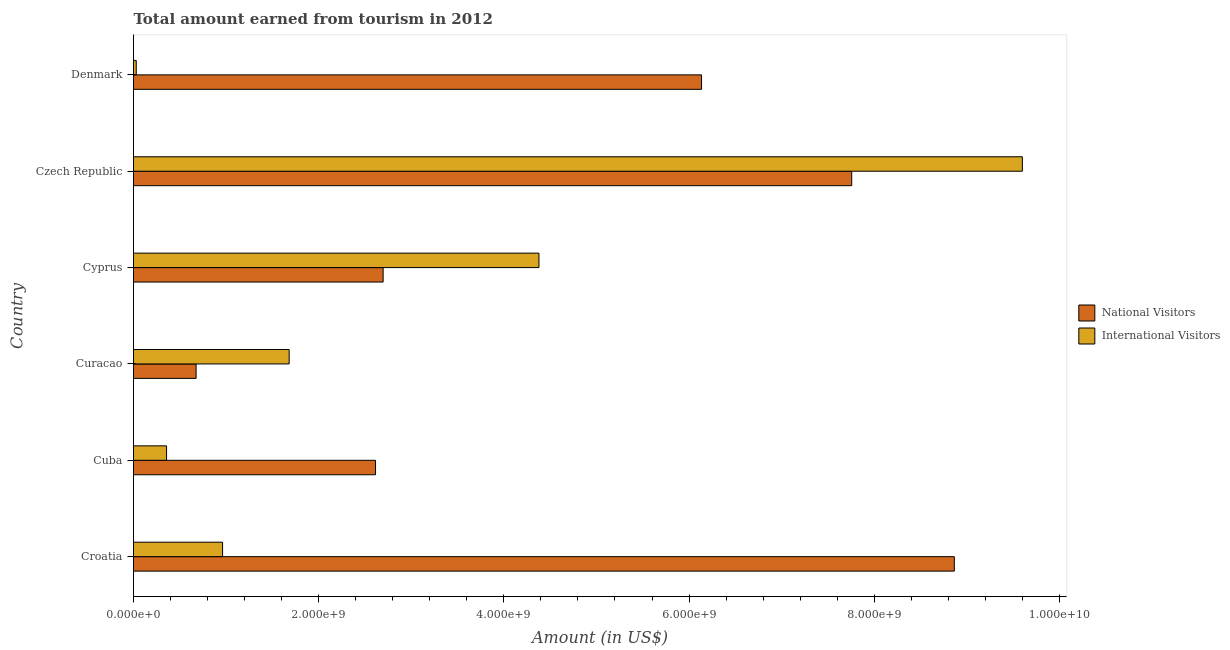Are the number of bars on each tick of the Y-axis equal?
Provide a succinct answer. Yes. How many bars are there on the 6th tick from the bottom?
Provide a short and direct response. 2. What is the label of the 3rd group of bars from the top?
Your response must be concise. Cyprus. In how many cases, is the number of bars for a given country not equal to the number of legend labels?
Offer a terse response. 0. What is the amount earned from national visitors in Cyprus?
Make the answer very short. 2.70e+09. Across all countries, what is the maximum amount earned from international visitors?
Offer a very short reply. 9.60e+09. Across all countries, what is the minimum amount earned from national visitors?
Offer a very short reply. 6.76e+08. In which country was the amount earned from international visitors maximum?
Your answer should be compact. Czech Republic. What is the total amount earned from international visitors in the graph?
Give a very brief answer. 1.70e+1. What is the difference between the amount earned from international visitors in Curacao and that in Czech Republic?
Your answer should be compact. -7.92e+09. What is the difference between the amount earned from international visitors in Curacao and the amount earned from national visitors in Denmark?
Make the answer very short. -4.45e+09. What is the average amount earned from national visitors per country?
Keep it short and to the point. 4.79e+09. What is the difference between the amount earned from national visitors and amount earned from international visitors in Denmark?
Your answer should be compact. 6.11e+09. In how many countries, is the amount earned from national visitors greater than 2800000000 US$?
Keep it short and to the point. 3. What is the ratio of the amount earned from international visitors in Cuba to that in Cyprus?
Offer a very short reply. 0.08. Is the difference between the amount earned from national visitors in Curacao and Czech Republic greater than the difference between the amount earned from international visitors in Curacao and Czech Republic?
Your answer should be compact. Yes. What is the difference between the highest and the second highest amount earned from national visitors?
Make the answer very short. 1.11e+09. What is the difference between the highest and the lowest amount earned from international visitors?
Keep it short and to the point. 9.57e+09. In how many countries, is the amount earned from international visitors greater than the average amount earned from international visitors taken over all countries?
Your response must be concise. 2. Is the sum of the amount earned from national visitors in Curacao and Czech Republic greater than the maximum amount earned from international visitors across all countries?
Keep it short and to the point. No. What does the 2nd bar from the top in Cuba represents?
Provide a short and direct response. National Visitors. What does the 2nd bar from the bottom in Curacao represents?
Offer a terse response. International Visitors. How many bars are there?
Provide a short and direct response. 12. What is the difference between two consecutive major ticks on the X-axis?
Your answer should be very brief. 2.00e+09. Are the values on the major ticks of X-axis written in scientific E-notation?
Your response must be concise. Yes. Does the graph contain any zero values?
Provide a short and direct response. No. Where does the legend appear in the graph?
Provide a succinct answer. Center right. What is the title of the graph?
Make the answer very short. Total amount earned from tourism in 2012. Does "National Tourists" appear as one of the legend labels in the graph?
Give a very brief answer. No. What is the Amount (in US$) of National Visitors in Croatia?
Offer a very short reply. 8.86e+09. What is the Amount (in US$) in International Visitors in Croatia?
Your answer should be compact. 9.62e+08. What is the Amount (in US$) of National Visitors in Cuba?
Your response must be concise. 2.61e+09. What is the Amount (in US$) in International Visitors in Cuba?
Offer a very short reply. 3.57e+08. What is the Amount (in US$) of National Visitors in Curacao?
Your answer should be compact. 6.76e+08. What is the Amount (in US$) of International Visitors in Curacao?
Ensure brevity in your answer.  1.68e+09. What is the Amount (in US$) of National Visitors in Cyprus?
Offer a terse response. 2.70e+09. What is the Amount (in US$) in International Visitors in Cyprus?
Provide a short and direct response. 4.38e+09. What is the Amount (in US$) in National Visitors in Czech Republic?
Your answer should be very brief. 7.76e+09. What is the Amount (in US$) in International Visitors in Czech Republic?
Your response must be concise. 9.60e+09. What is the Amount (in US$) in National Visitors in Denmark?
Give a very brief answer. 6.14e+09. What is the Amount (in US$) in International Visitors in Denmark?
Offer a terse response. 2.96e+07. Across all countries, what is the maximum Amount (in US$) in National Visitors?
Your answer should be compact. 8.86e+09. Across all countries, what is the maximum Amount (in US$) of International Visitors?
Provide a short and direct response. 9.60e+09. Across all countries, what is the minimum Amount (in US$) in National Visitors?
Provide a succinct answer. 6.76e+08. Across all countries, what is the minimum Amount (in US$) in International Visitors?
Your response must be concise. 2.96e+07. What is the total Amount (in US$) in National Visitors in the graph?
Ensure brevity in your answer.  2.87e+1. What is the total Amount (in US$) in International Visitors in the graph?
Keep it short and to the point. 1.70e+1. What is the difference between the Amount (in US$) of National Visitors in Croatia and that in Cuba?
Your answer should be very brief. 6.25e+09. What is the difference between the Amount (in US$) in International Visitors in Croatia and that in Cuba?
Give a very brief answer. 6.05e+08. What is the difference between the Amount (in US$) in National Visitors in Croatia and that in Curacao?
Keep it short and to the point. 8.19e+09. What is the difference between the Amount (in US$) in International Visitors in Croatia and that in Curacao?
Give a very brief answer. -7.19e+08. What is the difference between the Amount (in US$) of National Visitors in Croatia and that in Cyprus?
Provide a short and direct response. 6.17e+09. What is the difference between the Amount (in US$) of International Visitors in Croatia and that in Cyprus?
Provide a short and direct response. -3.42e+09. What is the difference between the Amount (in US$) of National Visitors in Croatia and that in Czech Republic?
Your answer should be very brief. 1.11e+09. What is the difference between the Amount (in US$) in International Visitors in Croatia and that in Czech Republic?
Ensure brevity in your answer.  -8.64e+09. What is the difference between the Amount (in US$) of National Visitors in Croatia and that in Denmark?
Offer a terse response. 2.73e+09. What is the difference between the Amount (in US$) of International Visitors in Croatia and that in Denmark?
Offer a very short reply. 9.32e+08. What is the difference between the Amount (in US$) in National Visitors in Cuba and that in Curacao?
Ensure brevity in your answer.  1.94e+09. What is the difference between the Amount (in US$) of International Visitors in Cuba and that in Curacao?
Offer a terse response. -1.32e+09. What is the difference between the Amount (in US$) of National Visitors in Cuba and that in Cyprus?
Give a very brief answer. -8.20e+07. What is the difference between the Amount (in US$) of International Visitors in Cuba and that in Cyprus?
Give a very brief answer. -4.02e+09. What is the difference between the Amount (in US$) of National Visitors in Cuba and that in Czech Republic?
Make the answer very short. -5.14e+09. What is the difference between the Amount (in US$) of International Visitors in Cuba and that in Czech Republic?
Keep it short and to the point. -9.24e+09. What is the difference between the Amount (in US$) of National Visitors in Cuba and that in Denmark?
Keep it short and to the point. -3.52e+09. What is the difference between the Amount (in US$) of International Visitors in Cuba and that in Denmark?
Offer a terse response. 3.27e+08. What is the difference between the Amount (in US$) of National Visitors in Curacao and that in Cyprus?
Provide a short and direct response. -2.02e+09. What is the difference between the Amount (in US$) in International Visitors in Curacao and that in Cyprus?
Ensure brevity in your answer.  -2.70e+09. What is the difference between the Amount (in US$) in National Visitors in Curacao and that in Czech Republic?
Provide a succinct answer. -7.08e+09. What is the difference between the Amount (in US$) in International Visitors in Curacao and that in Czech Republic?
Offer a very short reply. -7.92e+09. What is the difference between the Amount (in US$) of National Visitors in Curacao and that in Denmark?
Offer a terse response. -5.46e+09. What is the difference between the Amount (in US$) of International Visitors in Curacao and that in Denmark?
Your response must be concise. 1.65e+09. What is the difference between the Amount (in US$) in National Visitors in Cyprus and that in Czech Republic?
Keep it short and to the point. -5.06e+09. What is the difference between the Amount (in US$) in International Visitors in Cyprus and that in Czech Republic?
Offer a very short reply. -5.22e+09. What is the difference between the Amount (in US$) of National Visitors in Cyprus and that in Denmark?
Ensure brevity in your answer.  -3.44e+09. What is the difference between the Amount (in US$) of International Visitors in Cyprus and that in Denmark?
Offer a terse response. 4.35e+09. What is the difference between the Amount (in US$) of National Visitors in Czech Republic and that in Denmark?
Your response must be concise. 1.62e+09. What is the difference between the Amount (in US$) of International Visitors in Czech Republic and that in Denmark?
Make the answer very short. 9.57e+09. What is the difference between the Amount (in US$) of National Visitors in Croatia and the Amount (in US$) of International Visitors in Cuba?
Make the answer very short. 8.51e+09. What is the difference between the Amount (in US$) of National Visitors in Croatia and the Amount (in US$) of International Visitors in Curacao?
Provide a short and direct response. 7.18e+09. What is the difference between the Amount (in US$) in National Visitors in Croatia and the Amount (in US$) in International Visitors in Cyprus?
Provide a succinct answer. 4.49e+09. What is the difference between the Amount (in US$) of National Visitors in Croatia and the Amount (in US$) of International Visitors in Czech Republic?
Provide a succinct answer. -7.35e+08. What is the difference between the Amount (in US$) in National Visitors in Croatia and the Amount (in US$) in International Visitors in Denmark?
Provide a succinct answer. 8.84e+09. What is the difference between the Amount (in US$) of National Visitors in Cuba and the Amount (in US$) of International Visitors in Curacao?
Your response must be concise. 9.33e+08. What is the difference between the Amount (in US$) of National Visitors in Cuba and the Amount (in US$) of International Visitors in Cyprus?
Give a very brief answer. -1.76e+09. What is the difference between the Amount (in US$) of National Visitors in Cuba and the Amount (in US$) of International Visitors in Czech Republic?
Give a very brief answer. -6.99e+09. What is the difference between the Amount (in US$) of National Visitors in Cuba and the Amount (in US$) of International Visitors in Denmark?
Your answer should be very brief. 2.58e+09. What is the difference between the Amount (in US$) of National Visitors in Curacao and the Amount (in US$) of International Visitors in Cyprus?
Your answer should be very brief. -3.70e+09. What is the difference between the Amount (in US$) in National Visitors in Curacao and the Amount (in US$) in International Visitors in Czech Republic?
Your answer should be compact. -8.92e+09. What is the difference between the Amount (in US$) of National Visitors in Curacao and the Amount (in US$) of International Visitors in Denmark?
Your answer should be very brief. 6.46e+08. What is the difference between the Amount (in US$) in National Visitors in Cyprus and the Amount (in US$) in International Visitors in Czech Republic?
Your response must be concise. -6.90e+09. What is the difference between the Amount (in US$) in National Visitors in Cyprus and the Amount (in US$) in International Visitors in Denmark?
Offer a terse response. 2.67e+09. What is the difference between the Amount (in US$) of National Visitors in Czech Republic and the Amount (in US$) of International Visitors in Denmark?
Your answer should be very brief. 7.73e+09. What is the average Amount (in US$) in National Visitors per country?
Give a very brief answer. 4.79e+09. What is the average Amount (in US$) in International Visitors per country?
Your response must be concise. 2.83e+09. What is the difference between the Amount (in US$) in National Visitors and Amount (in US$) in International Visitors in Croatia?
Give a very brief answer. 7.90e+09. What is the difference between the Amount (in US$) of National Visitors and Amount (in US$) of International Visitors in Cuba?
Provide a succinct answer. 2.26e+09. What is the difference between the Amount (in US$) of National Visitors and Amount (in US$) of International Visitors in Curacao?
Provide a short and direct response. -1.00e+09. What is the difference between the Amount (in US$) in National Visitors and Amount (in US$) in International Visitors in Cyprus?
Your response must be concise. -1.68e+09. What is the difference between the Amount (in US$) in National Visitors and Amount (in US$) in International Visitors in Czech Republic?
Offer a terse response. -1.84e+09. What is the difference between the Amount (in US$) of National Visitors and Amount (in US$) of International Visitors in Denmark?
Your answer should be very brief. 6.11e+09. What is the ratio of the Amount (in US$) of National Visitors in Croatia to that in Cuba?
Provide a succinct answer. 3.39. What is the ratio of the Amount (in US$) in International Visitors in Croatia to that in Cuba?
Offer a very short reply. 2.69. What is the ratio of the Amount (in US$) of National Visitors in Croatia to that in Curacao?
Make the answer very short. 13.11. What is the ratio of the Amount (in US$) of International Visitors in Croatia to that in Curacao?
Provide a short and direct response. 0.57. What is the ratio of the Amount (in US$) in National Visitors in Croatia to that in Cyprus?
Provide a short and direct response. 3.29. What is the ratio of the Amount (in US$) in International Visitors in Croatia to that in Cyprus?
Provide a succinct answer. 0.22. What is the ratio of the Amount (in US$) of National Visitors in Croatia to that in Czech Republic?
Make the answer very short. 1.14. What is the ratio of the Amount (in US$) in International Visitors in Croatia to that in Czech Republic?
Your answer should be very brief. 0.1. What is the ratio of the Amount (in US$) in National Visitors in Croatia to that in Denmark?
Provide a short and direct response. 1.45. What is the ratio of the Amount (in US$) of International Visitors in Croatia to that in Denmark?
Your answer should be compact. 32.5. What is the ratio of the Amount (in US$) in National Visitors in Cuba to that in Curacao?
Your response must be concise. 3.87. What is the ratio of the Amount (in US$) in International Visitors in Cuba to that in Curacao?
Keep it short and to the point. 0.21. What is the ratio of the Amount (in US$) of National Visitors in Cuba to that in Cyprus?
Your answer should be compact. 0.97. What is the ratio of the Amount (in US$) in International Visitors in Cuba to that in Cyprus?
Give a very brief answer. 0.08. What is the ratio of the Amount (in US$) in National Visitors in Cuba to that in Czech Republic?
Provide a succinct answer. 0.34. What is the ratio of the Amount (in US$) of International Visitors in Cuba to that in Czech Republic?
Your response must be concise. 0.04. What is the ratio of the Amount (in US$) of National Visitors in Cuba to that in Denmark?
Your answer should be compact. 0.43. What is the ratio of the Amount (in US$) in International Visitors in Cuba to that in Denmark?
Keep it short and to the point. 12.06. What is the ratio of the Amount (in US$) of National Visitors in Curacao to that in Cyprus?
Your response must be concise. 0.25. What is the ratio of the Amount (in US$) of International Visitors in Curacao to that in Cyprus?
Your answer should be compact. 0.38. What is the ratio of the Amount (in US$) of National Visitors in Curacao to that in Czech Republic?
Offer a terse response. 0.09. What is the ratio of the Amount (in US$) in International Visitors in Curacao to that in Czech Republic?
Ensure brevity in your answer.  0.18. What is the ratio of the Amount (in US$) in National Visitors in Curacao to that in Denmark?
Make the answer very short. 0.11. What is the ratio of the Amount (in US$) in International Visitors in Curacao to that in Denmark?
Offer a terse response. 56.79. What is the ratio of the Amount (in US$) of National Visitors in Cyprus to that in Czech Republic?
Offer a very short reply. 0.35. What is the ratio of the Amount (in US$) in International Visitors in Cyprus to that in Czech Republic?
Provide a succinct answer. 0.46. What is the ratio of the Amount (in US$) in National Visitors in Cyprus to that in Denmark?
Provide a succinct answer. 0.44. What is the ratio of the Amount (in US$) in International Visitors in Cyprus to that in Denmark?
Ensure brevity in your answer.  147.94. What is the ratio of the Amount (in US$) in National Visitors in Czech Republic to that in Denmark?
Make the answer very short. 1.26. What is the ratio of the Amount (in US$) of International Visitors in Czech Republic to that in Denmark?
Your answer should be compact. 324.32. What is the difference between the highest and the second highest Amount (in US$) of National Visitors?
Your answer should be very brief. 1.11e+09. What is the difference between the highest and the second highest Amount (in US$) of International Visitors?
Make the answer very short. 5.22e+09. What is the difference between the highest and the lowest Amount (in US$) in National Visitors?
Offer a very short reply. 8.19e+09. What is the difference between the highest and the lowest Amount (in US$) in International Visitors?
Give a very brief answer. 9.57e+09. 